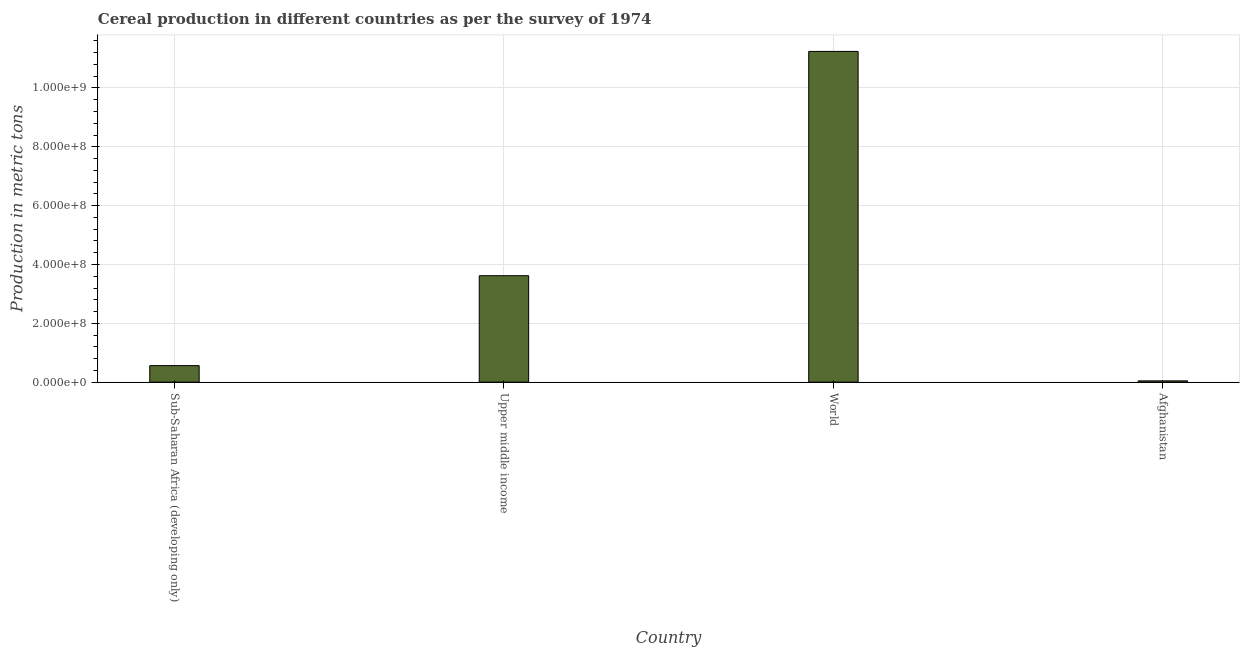What is the title of the graph?
Provide a succinct answer. Cereal production in different countries as per the survey of 1974. What is the label or title of the X-axis?
Make the answer very short. Country. What is the label or title of the Y-axis?
Your response must be concise. Production in metric tons. What is the cereal production in Upper middle income?
Give a very brief answer. 3.62e+08. Across all countries, what is the maximum cereal production?
Your answer should be compact. 1.12e+09. Across all countries, what is the minimum cereal production?
Your answer should be very brief. 4.35e+06. In which country was the cereal production minimum?
Your answer should be compact. Afghanistan. What is the sum of the cereal production?
Give a very brief answer. 1.55e+09. What is the difference between the cereal production in Afghanistan and World?
Your answer should be compact. -1.12e+09. What is the average cereal production per country?
Provide a short and direct response. 3.87e+08. What is the median cereal production?
Your answer should be very brief. 2.09e+08. What is the ratio of the cereal production in Afghanistan to that in Upper middle income?
Your response must be concise. 0.01. What is the difference between the highest and the second highest cereal production?
Make the answer very short. 7.62e+08. Is the sum of the cereal production in Sub-Saharan Africa (developing only) and World greater than the maximum cereal production across all countries?
Provide a succinct answer. Yes. What is the difference between the highest and the lowest cereal production?
Make the answer very short. 1.12e+09. In how many countries, is the cereal production greater than the average cereal production taken over all countries?
Offer a very short reply. 1. Are all the bars in the graph horizontal?
Provide a succinct answer. No. What is the difference between two consecutive major ticks on the Y-axis?
Offer a very short reply. 2.00e+08. What is the Production in metric tons of Sub-Saharan Africa (developing only)?
Provide a short and direct response. 5.61e+07. What is the Production in metric tons of Upper middle income?
Your answer should be compact. 3.62e+08. What is the Production in metric tons in World?
Offer a terse response. 1.12e+09. What is the Production in metric tons in Afghanistan?
Provide a succinct answer. 4.35e+06. What is the difference between the Production in metric tons in Sub-Saharan Africa (developing only) and Upper middle income?
Your answer should be compact. -3.06e+08. What is the difference between the Production in metric tons in Sub-Saharan Africa (developing only) and World?
Offer a very short reply. -1.07e+09. What is the difference between the Production in metric tons in Sub-Saharan Africa (developing only) and Afghanistan?
Provide a short and direct response. 5.18e+07. What is the difference between the Production in metric tons in Upper middle income and World?
Offer a very short reply. -7.62e+08. What is the difference between the Production in metric tons in Upper middle income and Afghanistan?
Your response must be concise. 3.57e+08. What is the difference between the Production in metric tons in World and Afghanistan?
Make the answer very short. 1.12e+09. What is the ratio of the Production in metric tons in Sub-Saharan Africa (developing only) to that in Upper middle income?
Ensure brevity in your answer.  0.15. What is the ratio of the Production in metric tons in Upper middle income to that in World?
Your answer should be compact. 0.32. What is the ratio of the Production in metric tons in Upper middle income to that in Afghanistan?
Offer a very short reply. 83.15. What is the ratio of the Production in metric tons in World to that in Afghanistan?
Ensure brevity in your answer.  258.37. 